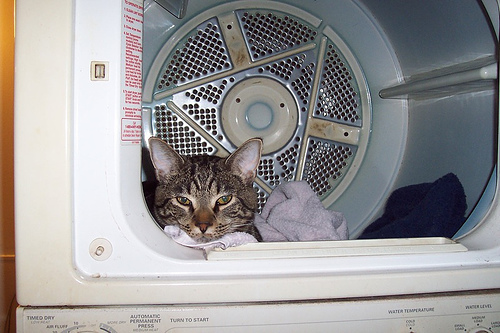<image>
Can you confirm if the cat is next to the dryer? No. The cat is not positioned next to the dryer. They are located in different areas of the scene. Where is the cat in relation to the dryer? Is it under the dryer? No. The cat is not positioned under the dryer. The vertical relationship between these objects is different. Is there a cat in the dryer? Yes. The cat is contained within or inside the dryer, showing a containment relationship. 